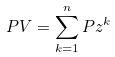Convert formula to latex. <formula><loc_0><loc_0><loc_500><loc_500>P V = \sum _ { k = 1 } ^ { n } P z ^ { k }</formula> 